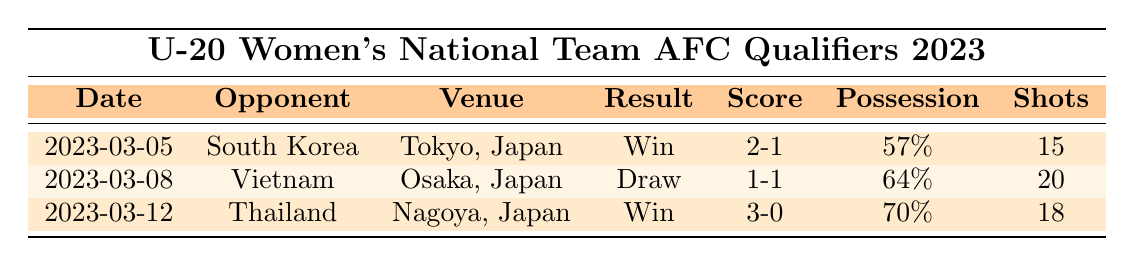What was the final score of the match against Vietnam? The score of the match against Vietnam on March 8, 2023, is shown in the table as 1-1.
Answer: 1-1 Who did Japan play against on March 5, 2023? The table lists the date March 5, 2023, with the opponent being South Korea.
Answer: South Korea How many shots did Japan take in the match against Thailand? The table indicates that Japan took 18 shots during the match against Thailand on March 12, 2023.
Answer: 18 What percentage possession did Japan have in the match against South Korea? According to the table, Japan had 57% possession during the match against South Korea on March 5, 2023.
Answer: 57% Did Japan win all their matches in the qualifiers? The table shows that Japan won against South Korea and Thailand, but drew with Vietnam, so they did not win all their matches.
Answer: No Which match had the highest shots taken by Japan? By comparing the shots against each opponent, Japan had 20 shots against Vietnam, which is the highest number listed in the table.
Answer: Vietnam What was the average percentage possession for Japan across all matches? The possessions are 57%, 64%, and 70%. To find the average: (57 + 64 + 70) / 3 = 63.67%.
Answer: 63.67% In which match did Japan score the most goals? Japan scored 3 goals in the match against Thailand on March 12, 2023, which is more than in any other match.
Answer: Thailand What was the result of the match played on March 8, 2023? The table shows that the result of the match on March 8, 2023, against Vietnam was a draw.
Answer: Draw How many goals did Aki Yoshida score in the qualifiers? The table indicates that Aki Yoshida scored 1 goal in the match against Vietnam on March 8, 2023.
Answer: 1 